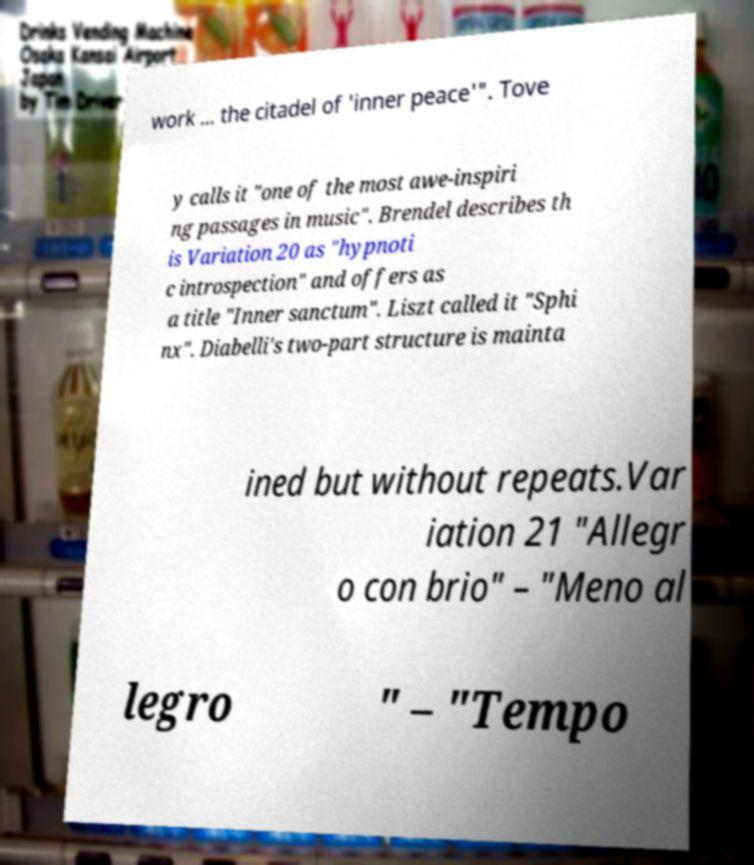There's text embedded in this image that I need extracted. Can you transcribe it verbatim? work ... the citadel of 'inner peace'". Tove y calls it "one of the most awe-inspiri ng passages in music". Brendel describes th is Variation 20 as "hypnoti c introspection" and offers as a title "Inner sanctum". Liszt called it "Sphi nx". Diabelli's two-part structure is mainta ined but without repeats.Var iation 21 "Allegr o con brio" – "Meno al legro " – "Tempo 